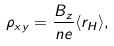Convert formula to latex. <formula><loc_0><loc_0><loc_500><loc_500>\rho _ { x y } = \frac { B _ { z } } { n e } \langle r _ { H } \rangle ,</formula> 